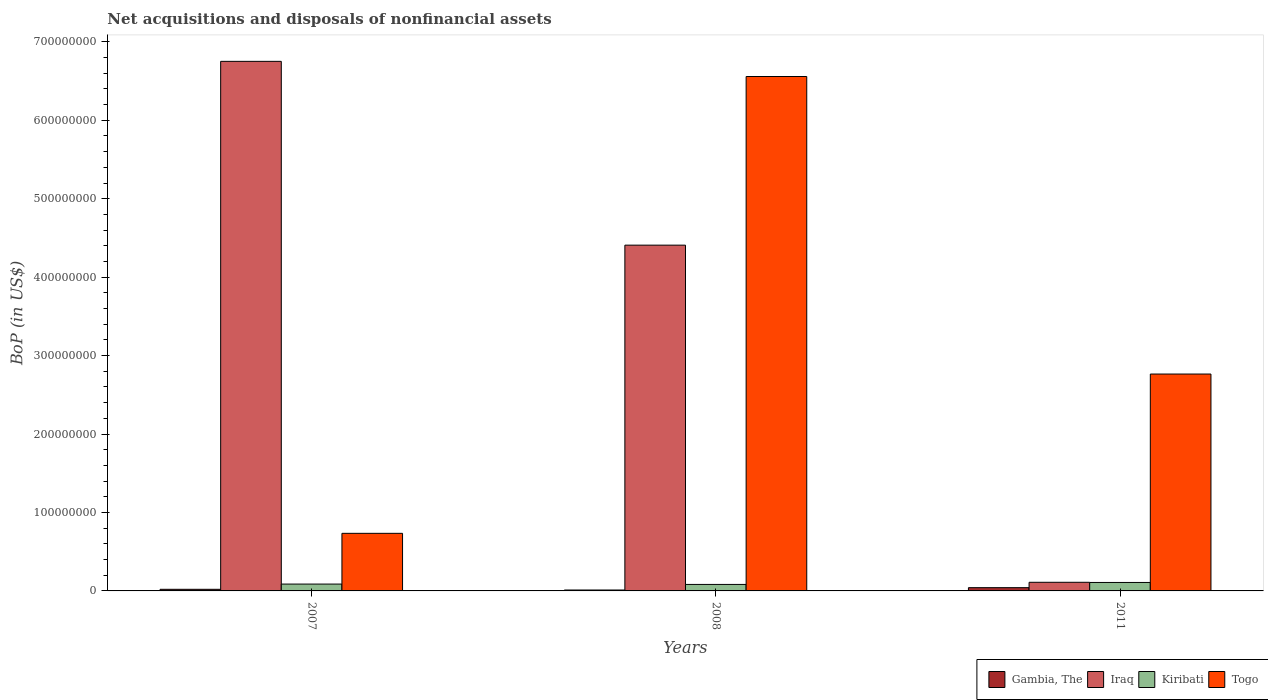In how many cases, is the number of bars for a given year not equal to the number of legend labels?
Provide a short and direct response. 0. What is the Balance of Payments in Togo in 2008?
Offer a terse response. 6.56e+08. Across all years, what is the maximum Balance of Payments in Iraq?
Provide a short and direct response. 6.75e+08. Across all years, what is the minimum Balance of Payments in Iraq?
Give a very brief answer. 1.10e+07. In which year was the Balance of Payments in Iraq minimum?
Your answer should be very brief. 2011. What is the total Balance of Payments in Togo in the graph?
Make the answer very short. 1.01e+09. What is the difference between the Balance of Payments in Togo in 2008 and that in 2011?
Provide a succinct answer. 3.79e+08. What is the difference between the Balance of Payments in Iraq in 2007 and the Balance of Payments in Gambia, The in 2011?
Your response must be concise. 6.71e+08. What is the average Balance of Payments in Kiribati per year?
Make the answer very short. 9.27e+06. In the year 2007, what is the difference between the Balance of Payments in Gambia, The and Balance of Payments in Kiribati?
Provide a short and direct response. -6.67e+06. In how many years, is the Balance of Payments in Togo greater than 420000000 US$?
Offer a terse response. 1. What is the ratio of the Balance of Payments in Togo in 2007 to that in 2011?
Provide a succinct answer. 0.27. Is the Balance of Payments in Gambia, The in 2007 less than that in 2011?
Your response must be concise. Yes. Is the difference between the Balance of Payments in Gambia, The in 2007 and 2011 greater than the difference between the Balance of Payments in Kiribati in 2007 and 2011?
Provide a succinct answer. No. What is the difference between the highest and the second highest Balance of Payments in Gambia, The?
Offer a very short reply. 2.09e+06. What is the difference between the highest and the lowest Balance of Payments in Kiribati?
Offer a terse response. 2.51e+06. In how many years, is the Balance of Payments in Iraq greater than the average Balance of Payments in Iraq taken over all years?
Offer a terse response. 2. Is it the case that in every year, the sum of the Balance of Payments in Gambia, The and Balance of Payments in Kiribati is greater than the sum of Balance of Payments in Iraq and Balance of Payments in Togo?
Make the answer very short. No. What does the 2nd bar from the left in 2008 represents?
Provide a short and direct response. Iraq. What does the 3rd bar from the right in 2007 represents?
Provide a succinct answer. Iraq. Does the graph contain any zero values?
Your answer should be very brief. No. Does the graph contain grids?
Make the answer very short. No. What is the title of the graph?
Offer a terse response. Net acquisitions and disposals of nonfinancial assets. What is the label or title of the X-axis?
Give a very brief answer. Years. What is the label or title of the Y-axis?
Your response must be concise. BoP (in US$). What is the BoP (in US$) of Gambia, The in 2007?
Provide a short and direct response. 2.07e+06. What is the BoP (in US$) in Iraq in 2007?
Keep it short and to the point. 6.75e+08. What is the BoP (in US$) of Kiribati in 2007?
Offer a terse response. 8.74e+06. What is the BoP (in US$) in Togo in 2007?
Make the answer very short. 7.34e+07. What is the BoP (in US$) of Gambia, The in 2008?
Your response must be concise. 1.17e+06. What is the BoP (in US$) in Iraq in 2008?
Keep it short and to the point. 4.41e+08. What is the BoP (in US$) in Kiribati in 2008?
Your response must be concise. 8.28e+06. What is the BoP (in US$) in Togo in 2008?
Your answer should be very brief. 6.56e+08. What is the BoP (in US$) of Gambia, The in 2011?
Make the answer very short. 4.15e+06. What is the BoP (in US$) in Iraq in 2011?
Keep it short and to the point. 1.10e+07. What is the BoP (in US$) of Kiribati in 2011?
Provide a short and direct response. 1.08e+07. What is the BoP (in US$) in Togo in 2011?
Your answer should be compact. 2.76e+08. Across all years, what is the maximum BoP (in US$) of Gambia, The?
Your response must be concise. 4.15e+06. Across all years, what is the maximum BoP (in US$) in Iraq?
Your response must be concise. 6.75e+08. Across all years, what is the maximum BoP (in US$) in Kiribati?
Ensure brevity in your answer.  1.08e+07. Across all years, what is the maximum BoP (in US$) of Togo?
Offer a terse response. 6.56e+08. Across all years, what is the minimum BoP (in US$) in Gambia, The?
Offer a very short reply. 1.17e+06. Across all years, what is the minimum BoP (in US$) of Iraq?
Provide a short and direct response. 1.10e+07. Across all years, what is the minimum BoP (in US$) of Kiribati?
Your answer should be very brief. 8.28e+06. Across all years, what is the minimum BoP (in US$) in Togo?
Your answer should be very brief. 7.34e+07. What is the total BoP (in US$) of Gambia, The in the graph?
Your answer should be very brief. 7.39e+06. What is the total BoP (in US$) of Iraq in the graph?
Offer a terse response. 1.13e+09. What is the total BoP (in US$) in Kiribati in the graph?
Ensure brevity in your answer.  2.78e+07. What is the total BoP (in US$) of Togo in the graph?
Offer a terse response. 1.01e+09. What is the difference between the BoP (in US$) of Gambia, The in 2007 and that in 2008?
Give a very brief answer. 8.96e+05. What is the difference between the BoP (in US$) of Iraq in 2007 and that in 2008?
Your answer should be compact. 2.34e+08. What is the difference between the BoP (in US$) of Kiribati in 2007 and that in 2008?
Your answer should be very brief. 4.59e+05. What is the difference between the BoP (in US$) of Togo in 2007 and that in 2008?
Offer a very short reply. -5.82e+08. What is the difference between the BoP (in US$) in Gambia, The in 2007 and that in 2011?
Keep it short and to the point. -2.09e+06. What is the difference between the BoP (in US$) of Iraq in 2007 and that in 2011?
Make the answer very short. 6.64e+08. What is the difference between the BoP (in US$) of Kiribati in 2007 and that in 2011?
Give a very brief answer. -2.05e+06. What is the difference between the BoP (in US$) in Togo in 2007 and that in 2011?
Make the answer very short. -2.03e+08. What is the difference between the BoP (in US$) in Gambia, The in 2008 and that in 2011?
Ensure brevity in your answer.  -2.98e+06. What is the difference between the BoP (in US$) in Iraq in 2008 and that in 2011?
Give a very brief answer. 4.30e+08. What is the difference between the BoP (in US$) of Kiribati in 2008 and that in 2011?
Give a very brief answer. -2.51e+06. What is the difference between the BoP (in US$) of Togo in 2008 and that in 2011?
Offer a very short reply. 3.79e+08. What is the difference between the BoP (in US$) in Gambia, The in 2007 and the BoP (in US$) in Iraq in 2008?
Keep it short and to the point. -4.39e+08. What is the difference between the BoP (in US$) in Gambia, The in 2007 and the BoP (in US$) in Kiribati in 2008?
Give a very brief answer. -6.21e+06. What is the difference between the BoP (in US$) of Gambia, The in 2007 and the BoP (in US$) of Togo in 2008?
Your answer should be compact. -6.54e+08. What is the difference between the BoP (in US$) in Iraq in 2007 and the BoP (in US$) in Kiribati in 2008?
Give a very brief answer. 6.67e+08. What is the difference between the BoP (in US$) of Iraq in 2007 and the BoP (in US$) of Togo in 2008?
Make the answer very short. 1.93e+07. What is the difference between the BoP (in US$) in Kiribati in 2007 and the BoP (in US$) in Togo in 2008?
Offer a terse response. -6.47e+08. What is the difference between the BoP (in US$) of Gambia, The in 2007 and the BoP (in US$) of Iraq in 2011?
Keep it short and to the point. -8.93e+06. What is the difference between the BoP (in US$) in Gambia, The in 2007 and the BoP (in US$) in Kiribati in 2011?
Keep it short and to the point. -8.73e+06. What is the difference between the BoP (in US$) in Gambia, The in 2007 and the BoP (in US$) in Togo in 2011?
Make the answer very short. -2.74e+08. What is the difference between the BoP (in US$) of Iraq in 2007 and the BoP (in US$) of Kiribati in 2011?
Make the answer very short. 6.64e+08. What is the difference between the BoP (in US$) in Iraq in 2007 and the BoP (in US$) in Togo in 2011?
Offer a terse response. 3.99e+08. What is the difference between the BoP (in US$) in Kiribati in 2007 and the BoP (in US$) in Togo in 2011?
Provide a succinct answer. -2.68e+08. What is the difference between the BoP (in US$) of Gambia, The in 2008 and the BoP (in US$) of Iraq in 2011?
Provide a short and direct response. -9.83e+06. What is the difference between the BoP (in US$) in Gambia, The in 2008 and the BoP (in US$) in Kiribati in 2011?
Your answer should be very brief. -9.62e+06. What is the difference between the BoP (in US$) of Gambia, The in 2008 and the BoP (in US$) of Togo in 2011?
Provide a short and direct response. -2.75e+08. What is the difference between the BoP (in US$) of Iraq in 2008 and the BoP (in US$) of Kiribati in 2011?
Make the answer very short. 4.30e+08. What is the difference between the BoP (in US$) in Iraq in 2008 and the BoP (in US$) in Togo in 2011?
Offer a very short reply. 1.64e+08. What is the difference between the BoP (in US$) in Kiribati in 2008 and the BoP (in US$) in Togo in 2011?
Offer a terse response. -2.68e+08. What is the average BoP (in US$) in Gambia, The per year?
Ensure brevity in your answer.  2.46e+06. What is the average BoP (in US$) in Iraq per year?
Your response must be concise. 3.76e+08. What is the average BoP (in US$) of Kiribati per year?
Keep it short and to the point. 9.27e+06. What is the average BoP (in US$) of Togo per year?
Your answer should be compact. 3.35e+08. In the year 2007, what is the difference between the BoP (in US$) in Gambia, The and BoP (in US$) in Iraq?
Your answer should be compact. -6.73e+08. In the year 2007, what is the difference between the BoP (in US$) in Gambia, The and BoP (in US$) in Kiribati?
Give a very brief answer. -6.67e+06. In the year 2007, what is the difference between the BoP (in US$) of Gambia, The and BoP (in US$) of Togo?
Your answer should be very brief. -7.14e+07. In the year 2007, what is the difference between the BoP (in US$) in Iraq and BoP (in US$) in Kiribati?
Make the answer very short. 6.66e+08. In the year 2007, what is the difference between the BoP (in US$) of Iraq and BoP (in US$) of Togo?
Your answer should be compact. 6.02e+08. In the year 2007, what is the difference between the BoP (in US$) of Kiribati and BoP (in US$) of Togo?
Give a very brief answer. -6.47e+07. In the year 2008, what is the difference between the BoP (in US$) in Gambia, The and BoP (in US$) in Iraq?
Give a very brief answer. -4.40e+08. In the year 2008, what is the difference between the BoP (in US$) in Gambia, The and BoP (in US$) in Kiribati?
Your answer should be very brief. -7.11e+06. In the year 2008, what is the difference between the BoP (in US$) in Gambia, The and BoP (in US$) in Togo?
Your answer should be very brief. -6.55e+08. In the year 2008, what is the difference between the BoP (in US$) of Iraq and BoP (in US$) of Kiribati?
Give a very brief answer. 4.33e+08. In the year 2008, what is the difference between the BoP (in US$) in Iraq and BoP (in US$) in Togo?
Provide a succinct answer. -2.15e+08. In the year 2008, what is the difference between the BoP (in US$) of Kiribati and BoP (in US$) of Togo?
Give a very brief answer. -6.48e+08. In the year 2011, what is the difference between the BoP (in US$) of Gambia, The and BoP (in US$) of Iraq?
Offer a very short reply. -6.85e+06. In the year 2011, what is the difference between the BoP (in US$) of Gambia, The and BoP (in US$) of Kiribati?
Make the answer very short. -6.64e+06. In the year 2011, what is the difference between the BoP (in US$) in Gambia, The and BoP (in US$) in Togo?
Provide a succinct answer. -2.72e+08. In the year 2011, what is the difference between the BoP (in US$) of Iraq and BoP (in US$) of Kiribati?
Make the answer very short. 2.07e+05. In the year 2011, what is the difference between the BoP (in US$) of Iraq and BoP (in US$) of Togo?
Provide a short and direct response. -2.65e+08. In the year 2011, what is the difference between the BoP (in US$) in Kiribati and BoP (in US$) in Togo?
Your answer should be compact. -2.66e+08. What is the ratio of the BoP (in US$) of Gambia, The in 2007 to that in 2008?
Keep it short and to the point. 1.76. What is the ratio of the BoP (in US$) in Iraq in 2007 to that in 2008?
Give a very brief answer. 1.53. What is the ratio of the BoP (in US$) in Kiribati in 2007 to that in 2008?
Make the answer very short. 1.06. What is the ratio of the BoP (in US$) in Togo in 2007 to that in 2008?
Your answer should be very brief. 0.11. What is the ratio of the BoP (in US$) in Gambia, The in 2007 to that in 2011?
Ensure brevity in your answer.  0.5. What is the ratio of the BoP (in US$) in Iraq in 2007 to that in 2011?
Provide a short and direct response. 61.37. What is the ratio of the BoP (in US$) in Kiribati in 2007 to that in 2011?
Make the answer very short. 0.81. What is the ratio of the BoP (in US$) of Togo in 2007 to that in 2011?
Ensure brevity in your answer.  0.27. What is the ratio of the BoP (in US$) of Gambia, The in 2008 to that in 2011?
Ensure brevity in your answer.  0.28. What is the ratio of the BoP (in US$) in Iraq in 2008 to that in 2011?
Provide a short and direct response. 40.07. What is the ratio of the BoP (in US$) of Kiribati in 2008 to that in 2011?
Your answer should be very brief. 0.77. What is the ratio of the BoP (in US$) of Togo in 2008 to that in 2011?
Your response must be concise. 2.37. What is the difference between the highest and the second highest BoP (in US$) in Gambia, The?
Give a very brief answer. 2.09e+06. What is the difference between the highest and the second highest BoP (in US$) in Iraq?
Offer a very short reply. 2.34e+08. What is the difference between the highest and the second highest BoP (in US$) of Kiribati?
Give a very brief answer. 2.05e+06. What is the difference between the highest and the second highest BoP (in US$) in Togo?
Give a very brief answer. 3.79e+08. What is the difference between the highest and the lowest BoP (in US$) in Gambia, The?
Your answer should be very brief. 2.98e+06. What is the difference between the highest and the lowest BoP (in US$) in Iraq?
Offer a terse response. 6.64e+08. What is the difference between the highest and the lowest BoP (in US$) of Kiribati?
Make the answer very short. 2.51e+06. What is the difference between the highest and the lowest BoP (in US$) in Togo?
Your answer should be very brief. 5.82e+08. 